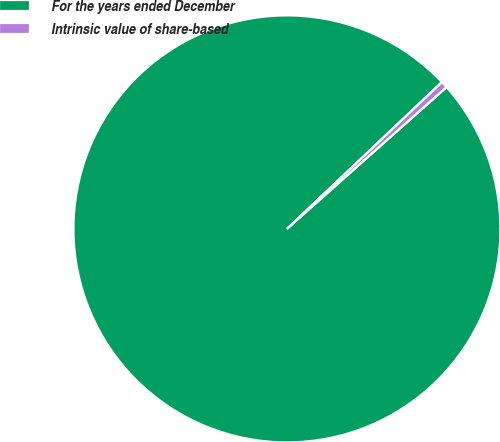Convert chart to OTSL. <chart><loc_0><loc_0><loc_500><loc_500><pie_chart><fcel>For the years ended December<fcel>Intrinsic value of share-based<nl><fcel>99.49%<fcel>0.51%<nl></chart> 